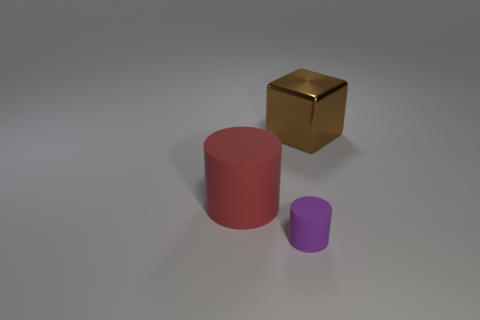Add 2 large blue rubber cylinders. How many objects exist? 5 Subtract all cylinders. How many objects are left? 1 Add 3 big red shiny objects. How many big red shiny objects exist? 3 Subtract 0 cyan blocks. How many objects are left? 3 Subtract all red matte objects. Subtract all tiny purple objects. How many objects are left? 1 Add 2 large rubber cylinders. How many large rubber cylinders are left? 3 